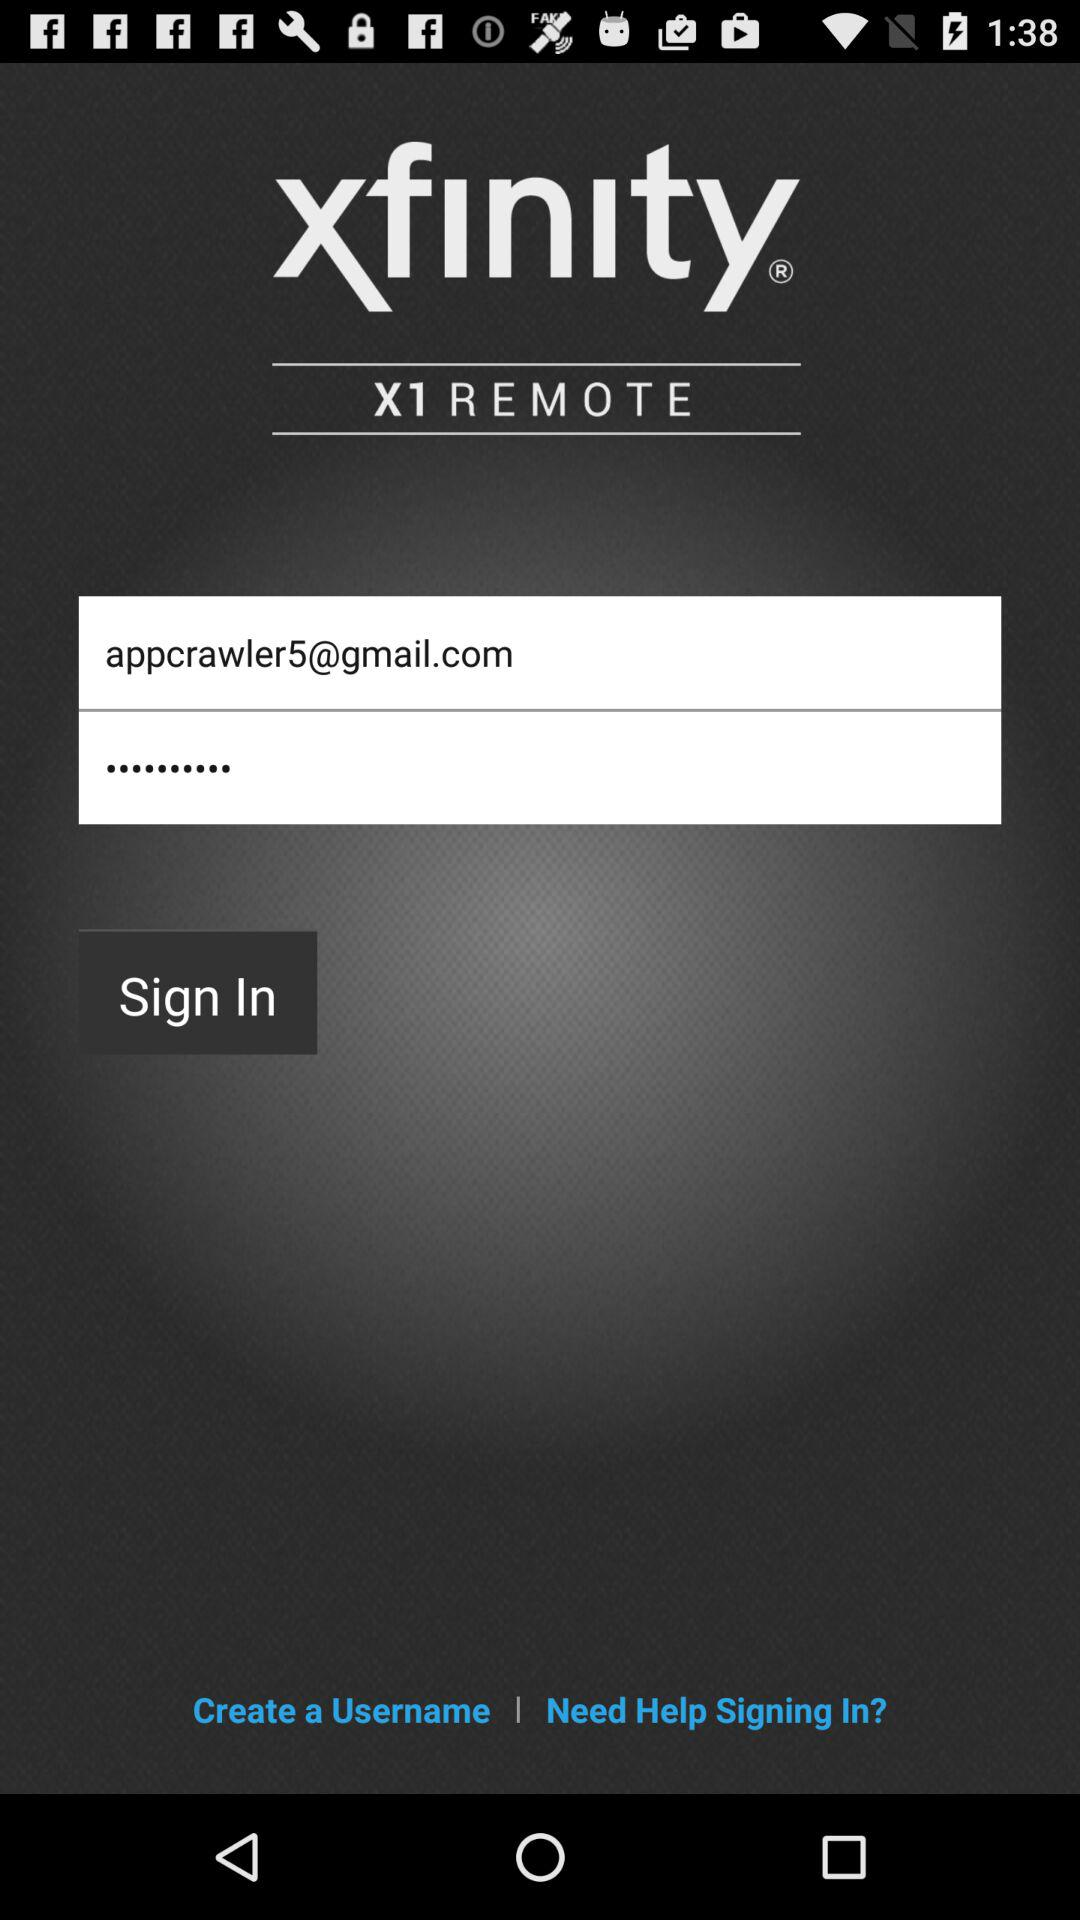What is the email address? The email address is appcrawler5@gmail.com. 